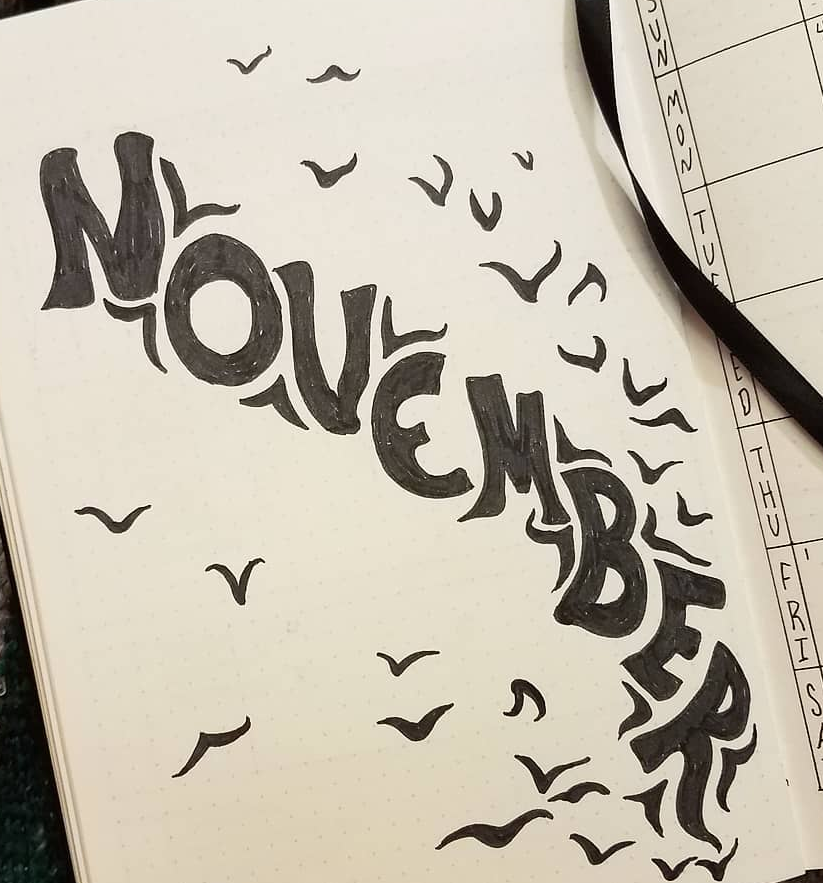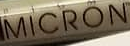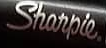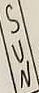What words are shown in these images in order, separated by a semicolon? NOVEMBER; MICRON; Sharpie.; SUN 